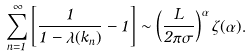Convert formula to latex. <formula><loc_0><loc_0><loc_500><loc_500>\sum _ { n = 1 } ^ { \infty } \left [ \frac { 1 } { 1 - \lambda ( k _ { n } ) } - 1 \right ] \sim \left ( \frac { L } { 2 \pi \sigma } \right ) ^ { \alpha } \zeta ( \alpha ) .</formula> 